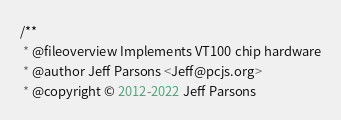<code> <loc_0><loc_0><loc_500><loc_500><_JavaScript_>/**
 * @fileoverview Implements VT100 chip hardware
 * @author Jeff Parsons <Jeff@pcjs.org>
 * @copyright © 2012-2022 Jeff Parsons</code> 